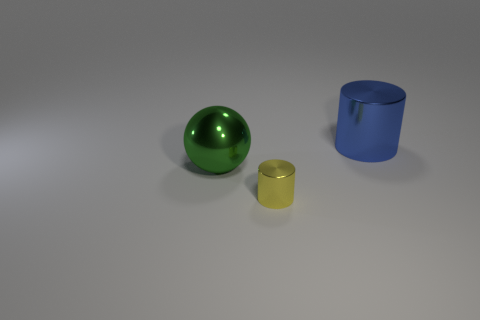Subtract all balls. How many objects are left? 2 Add 3 large metallic things. How many large metallic things are left? 5 Add 1 blue cylinders. How many blue cylinders exist? 2 Add 1 big metallic cylinders. How many objects exist? 4 Subtract all yellow cylinders. How many cylinders are left? 1 Subtract 0 cyan spheres. How many objects are left? 3 Subtract 1 cylinders. How many cylinders are left? 1 Subtract all red cylinders. Subtract all blue blocks. How many cylinders are left? 2 Subtract all green cubes. How many yellow cylinders are left? 1 Subtract all green spheres. Subtract all big red cylinders. How many objects are left? 2 